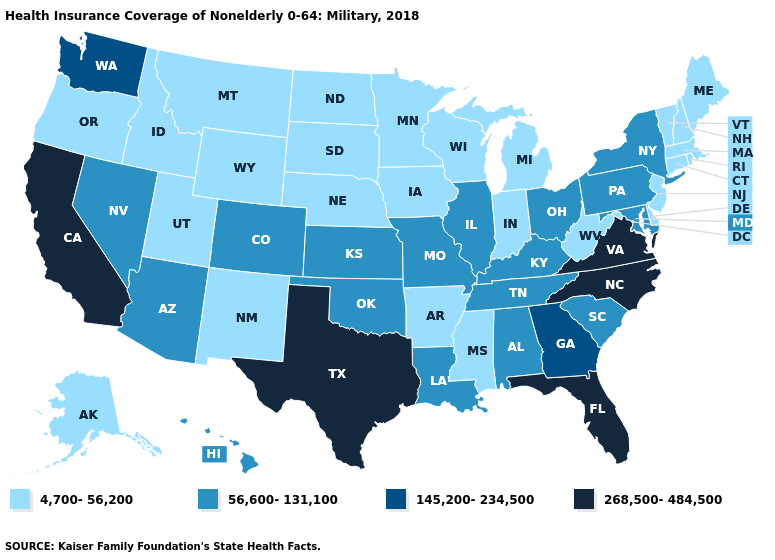What is the lowest value in the South?
Concise answer only. 4,700-56,200. What is the value of Louisiana?
Write a very short answer. 56,600-131,100. Name the states that have a value in the range 145,200-234,500?
Answer briefly. Georgia, Washington. How many symbols are there in the legend?
Concise answer only. 4. Does Illinois have a higher value than Tennessee?
Be succinct. No. Does the first symbol in the legend represent the smallest category?
Be succinct. Yes. Name the states that have a value in the range 4,700-56,200?
Short answer required. Alaska, Arkansas, Connecticut, Delaware, Idaho, Indiana, Iowa, Maine, Massachusetts, Michigan, Minnesota, Mississippi, Montana, Nebraska, New Hampshire, New Jersey, New Mexico, North Dakota, Oregon, Rhode Island, South Dakota, Utah, Vermont, West Virginia, Wisconsin, Wyoming. What is the highest value in states that border Alabama?
Concise answer only. 268,500-484,500. Does Florida have the highest value in the USA?
Write a very short answer. Yes. What is the value of Wyoming?
Concise answer only. 4,700-56,200. What is the value of North Carolina?
Give a very brief answer. 268,500-484,500. What is the lowest value in the South?
Give a very brief answer. 4,700-56,200. Does Arkansas have the highest value in the USA?
Be succinct. No. Does Utah have the same value as Mississippi?
Answer briefly. Yes. 